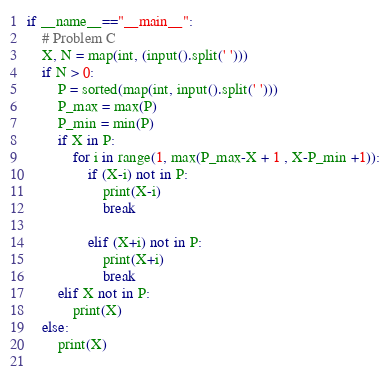<code> <loc_0><loc_0><loc_500><loc_500><_Python_>if __name__=="__main__":
    # Problem C
    X, N = map(int, (input().split(' ')))
    if N > 0:
        P = sorted(map(int, input().split(' ')))
        P_max = max(P)
        P_min = min(P)
        if X in P:
            for i in range(1, max(P_max-X + 1 , X-P_min +1)):
                if (X-i) not in P:
                    print(X-i)
                    break

                elif (X+i) not in P:
                    print(X+i)
                    break
        elif X not in P:
            print(X)
    else:
        print(X)
        </code> 